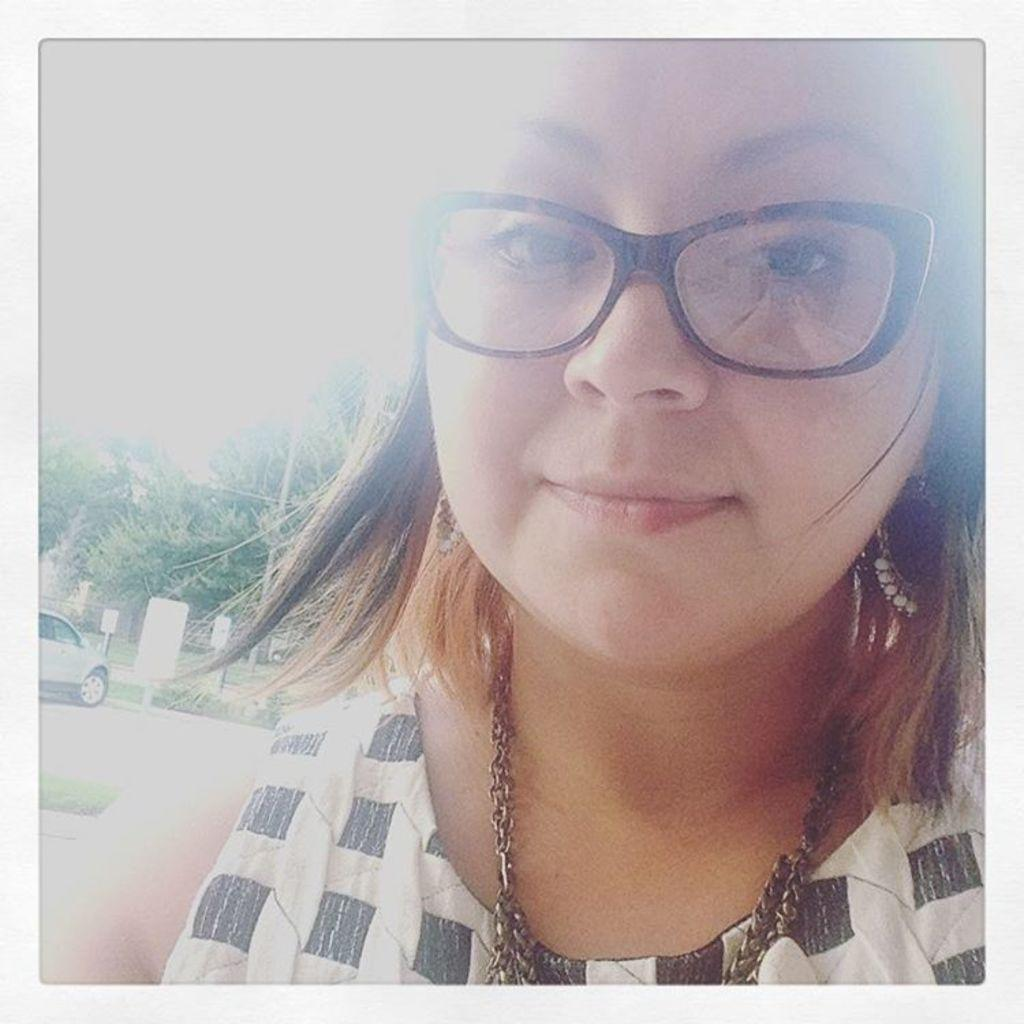Who is present in the image? There is a woman in the image. What is the woman wearing in the image? The woman is wearing spectacles in the image. What can be seen in the background of the image? There is a car, boards, and trees in the image. What type of receipt can be seen in the woman's hand in the image? There is no receipt visible in the woman's hand in the image. What type of structure is the woman standing in front of in the image? The provided facts do not mention any structure in the image, so it cannot be determined from the image. 